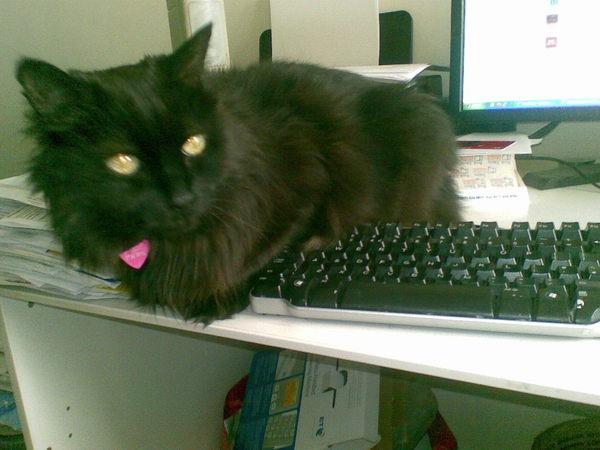Describe the objects in this image and their specific colors. I can see cat in darkgray, black, and darkgreen tones, keyboard in darkgray, black, darkgreen, teal, and lightgray tones, and tv in darkgray, white, teal, and lightblue tones in this image. 